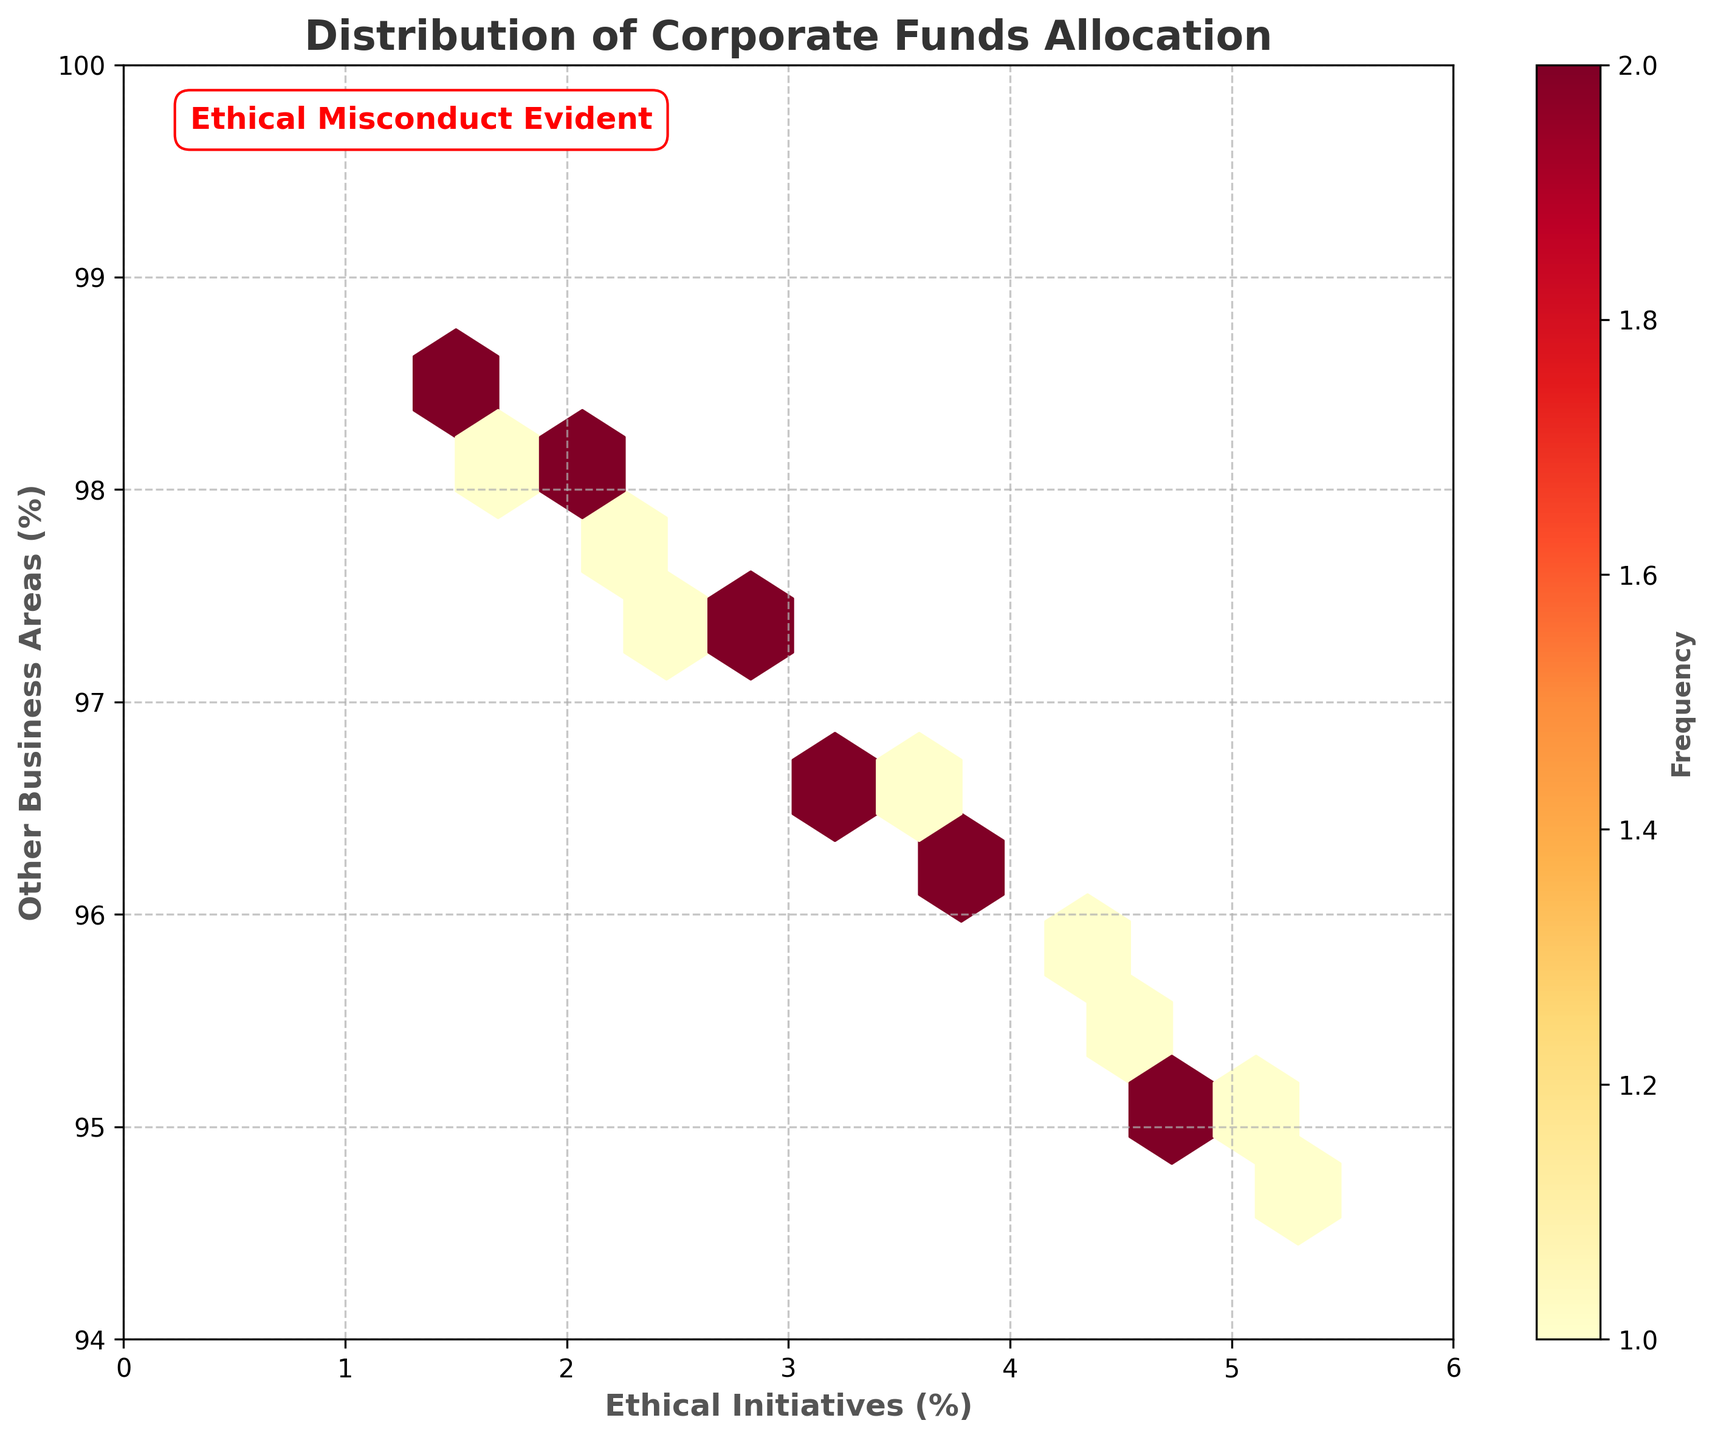What's the title of the plot? The title is generally found at the top of the figure. It is displayed in bold and larger font size relative to other text elements.
Answer: Distribution of Corporate Funds Allocation What does the color bar represent? The color bar indicates the frequency of data points within the hexagonal bins. A color gradient is used, ranging from lighter to darker shades to signify lower to higher frequencies, respectively.
Answer: Frequency What percentage range of Ethical Initiatives is the data mostly concentrated in? By observing the hexagons with the highest density (darkest color), the primary concentration can be inferred. It appears most data points are within the 2% to 4.5% range for Ethical Initiatives.
Answer: 2% to 4.5% How does the allocation to Other Business Areas compare to Ethical Initiatives overall? The y-axis represents Other Business Areas, and the x-axis represents Ethical Initiatives. Since most data points lie on the upper end of the y-axis and lower end of the x-axis, it is evident that funds are predominantly allocated to Other Business Areas rather than Ethical Initiatives.
Answer: Predominantly higher for Other Business Areas What grid size is used for the hexbin plot? Grid size defines the resolution of the hexbin plot. It can be inferred from the hexagon width across the plot. From the figure characteristics, a grid size of 10 is utilized.
Answer: 10 Where is the note "Ethical Misconduct Evident" located on the plot? The text is placed around the top-left corner of the plot. It is in bold red, enclosed in a white background box for emphasis, suggesting ethical concerns in funds allocation.
Answer: Top-left corner How do the axis limits help interpret the data spread? The x-axis ranges from 0 to 6, while the y-axis ranges from 94 to 100. These limits help to visualize the complete data range without clipping, thereby showing the entire funds allocation spread between Ethical Initiatives and Other Business Areas.
Answer: Demonstrates complete data range What does the data distribution imply about corporate priorities? The higher concentration of data points near the upper end of the y-axis and lower end of the x-axis illustrates a marginal allocation to Ethical Initiatives compared to substantial investments in Other Business Areas, hinting at possible ethical imbalances in corporate priorities.
Answer: Marginal Ethical Initiatives, substantial Other Business Areas What is the range of Ethical Initiatives in the dataset? By checking the x-axis and the spread of data points along it, the range can be identified from the lowest to the highest value. It spans from about 1.5% to 5.3%.
Answer: 1.5% to 5.3% In terms of frequency, is there evidence of ethical misconduct from the plot? The plot, particularly with the annotation "Ethical Misconduct Evident," and the observed data concentration (dense dark hexagons near low Ethical Initiatives percentages) suggest an observable pattern of unethical fund distribution practices within the corporation.
Answer: Yes 